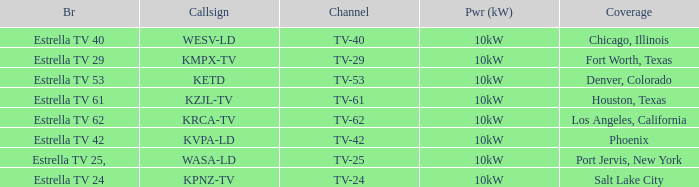List the branding name for channel tv-62. Estrella TV 62. 